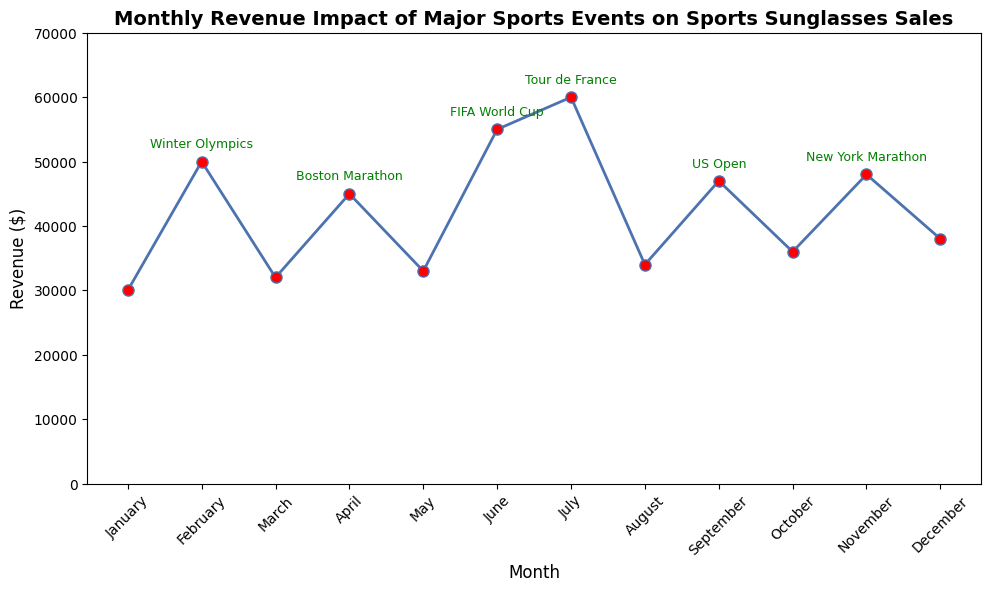What month had the highest revenue, and what event was associated with it? The highest revenue can be identified by looking at the maximum point on the chart. July has the highest revenue of $60,000, and it is associated with the Tour de France.
Answer: July, Tour de France Which event had the least impact on revenue, considering only the months with major events? To find the event with the least impact, compare the revenue of all months with major events and identify the lowest revenue. The Boston Marathon in April had the least impact, with revenue of $45,000.
Answer: Boston Marathon What is the average revenue for the months with no major events? To find the average revenue for months with no major events, sum the revenues for January, March, May, August, October, and December, then divide by the number of these months. (30000 + 32000 + 33000 + 34000 + 36000 + 38000) = 203000. Dividing 203000 by 6 gives the average revenue of these months.
Answer: $33,833.33 By how much does the revenue in July (Tour de France) differ from the revenue in February (Winter Olympics)? Subtract the revenue in February from the revenue in July to find the difference. $60,000 (July) - $50,000 (February) = $10,000.
Answer: $10,000 How did the revenue change from December to January of the following year? The revenue in December is $38,000, and in January it is $30,000 for the following year. Subtracting December's revenue from January's indicates the decrease: $30,000 - $38,000 = -$8,000.
Answer: Decreased by $8,000 Compare the revenue in months with the FIFA World Cup and US Open. Which one is higher and by how much? Compare the revenue values for June (FIFA World Cup) and September (US Open). June has $55,000, and September has $47,000. The difference is $55,000 - $47,000 = $8,000.
Answer: FIFA World Cup, $8,000 During which month(s) with no major sports events was the revenue closest to the average revenue of all months? First, calculate the average revenue of all months: (30000 + 50000 + 32000 + 45000 + 33000 + 55000 + 60000 + 34000 + 47000 + 36000 + 48000 + 38000)/12 = $43,083.33. Then, identify which month with no events had revenue closest to this average. The closest to $43,083.33 is October with a revenue of $36,000.
Answer: October Is there a discernible trend in revenue between months with major events compared to those without? Visually inspect the chart to compare the revenue levels of months with and without major events. Generally, months with major sports events show higher revenue peaks compared to months without major events, indicating a significant impact.
Answer: Months with major events generally have higher revenue What is the total revenue generated during months with major sports events? Sum the revenue of months with major sports events: $50,000 (February) + $45,000 (April) + $55,000 (June) + $60,000 (July) + $47,000 (September) + $48,000 (November) = $305,000.
Answer: $305,000 